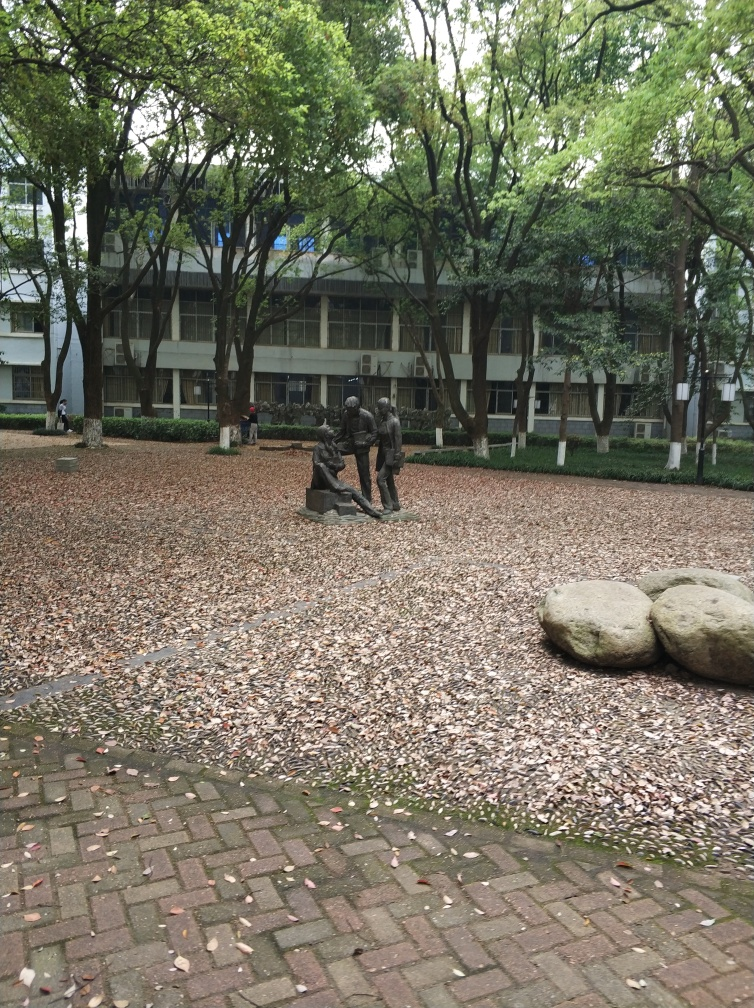Is there any distortion in the image? Upon close inspection, the image appears to be free from any apparent distortion. The lines and forms within the photograph, such as the brick patterns on the ground, the trunks of the trees, and the details of the statue, maintain consistent shapes and proportions, suggesting that the image accurately represents the scene as it would appear in reality. 